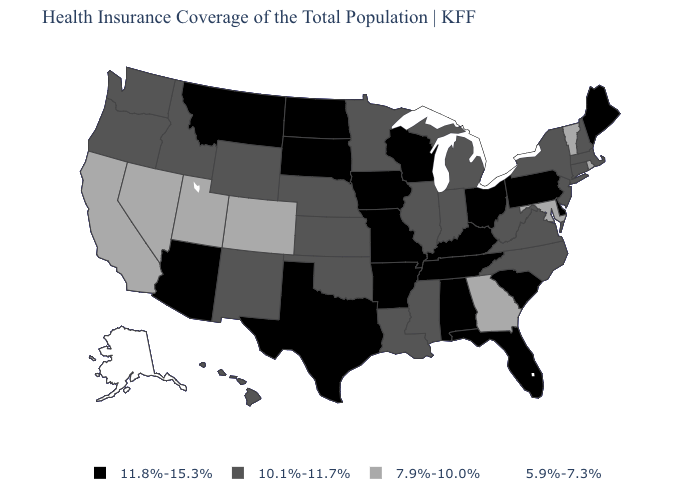Among the states that border South Carolina , which have the lowest value?
Quick response, please. Georgia. Among the states that border North Carolina , which have the lowest value?
Short answer required. Georgia. Does Wisconsin have the same value as Illinois?
Quick response, please. No. Does the map have missing data?
Keep it brief. No. Name the states that have a value in the range 11.8%-15.3%?
Short answer required. Alabama, Arizona, Arkansas, Delaware, Florida, Iowa, Kentucky, Maine, Missouri, Montana, North Dakota, Ohio, Pennsylvania, South Carolina, South Dakota, Tennessee, Texas, Wisconsin. What is the highest value in the USA?
Answer briefly. 11.8%-15.3%. Which states have the lowest value in the USA?
Be succinct. Alaska. Which states have the lowest value in the USA?
Be succinct. Alaska. What is the lowest value in the USA?
Short answer required. 5.9%-7.3%. Name the states that have a value in the range 5.9%-7.3%?
Quick response, please. Alaska. What is the highest value in the USA?
Concise answer only. 11.8%-15.3%. Name the states that have a value in the range 11.8%-15.3%?
Write a very short answer. Alabama, Arizona, Arkansas, Delaware, Florida, Iowa, Kentucky, Maine, Missouri, Montana, North Dakota, Ohio, Pennsylvania, South Carolina, South Dakota, Tennessee, Texas, Wisconsin. Name the states that have a value in the range 10.1%-11.7%?
Write a very short answer. Connecticut, Hawaii, Idaho, Illinois, Indiana, Kansas, Louisiana, Massachusetts, Michigan, Minnesota, Mississippi, Nebraska, New Hampshire, New Jersey, New Mexico, New York, North Carolina, Oklahoma, Oregon, Virginia, Washington, West Virginia, Wyoming. Name the states that have a value in the range 11.8%-15.3%?
Give a very brief answer. Alabama, Arizona, Arkansas, Delaware, Florida, Iowa, Kentucky, Maine, Missouri, Montana, North Dakota, Ohio, Pennsylvania, South Carolina, South Dakota, Tennessee, Texas, Wisconsin. 